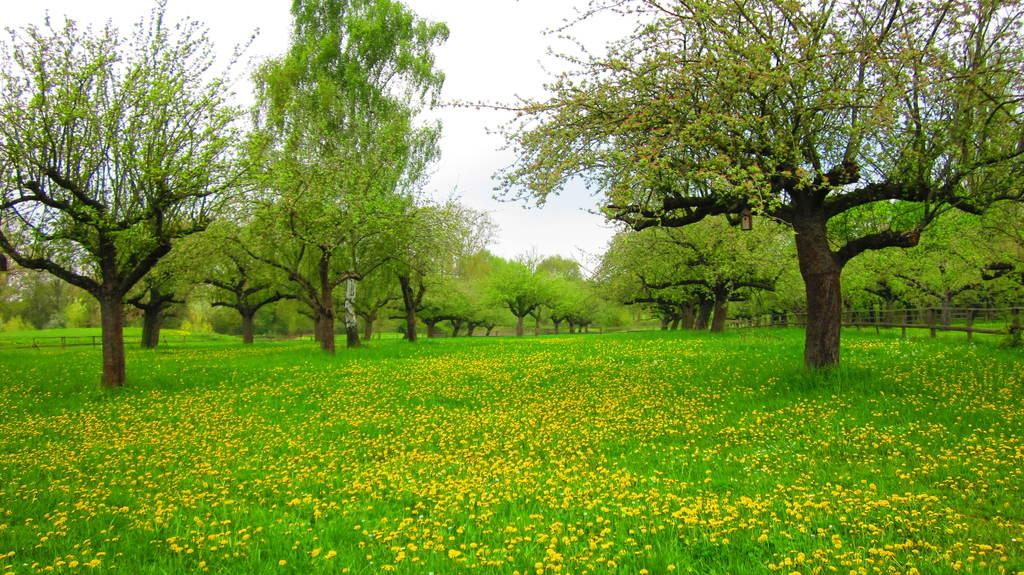What type of vegetation can be seen in the image? There are plants and many trees in the image. Are there any specific features of the plants? Yes, there are yellow color flowers on the plants. What can be seen in the background of the image? The sky is visible in the background of the image. How many steps can be seen leading up to the slope in the image? There are no steps or slopes present in the image; it features plants, trees, and yellow flowers. 